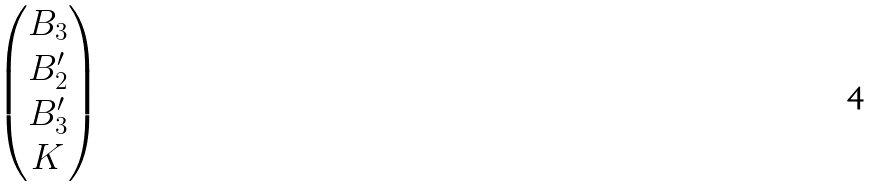Convert formula to latex. <formula><loc_0><loc_0><loc_500><loc_500>\begin{pmatrix} B _ { 3 } \\ B _ { 2 } ^ { \prime } \\ B _ { 3 } ^ { \prime } \\ K \end{pmatrix}</formula> 